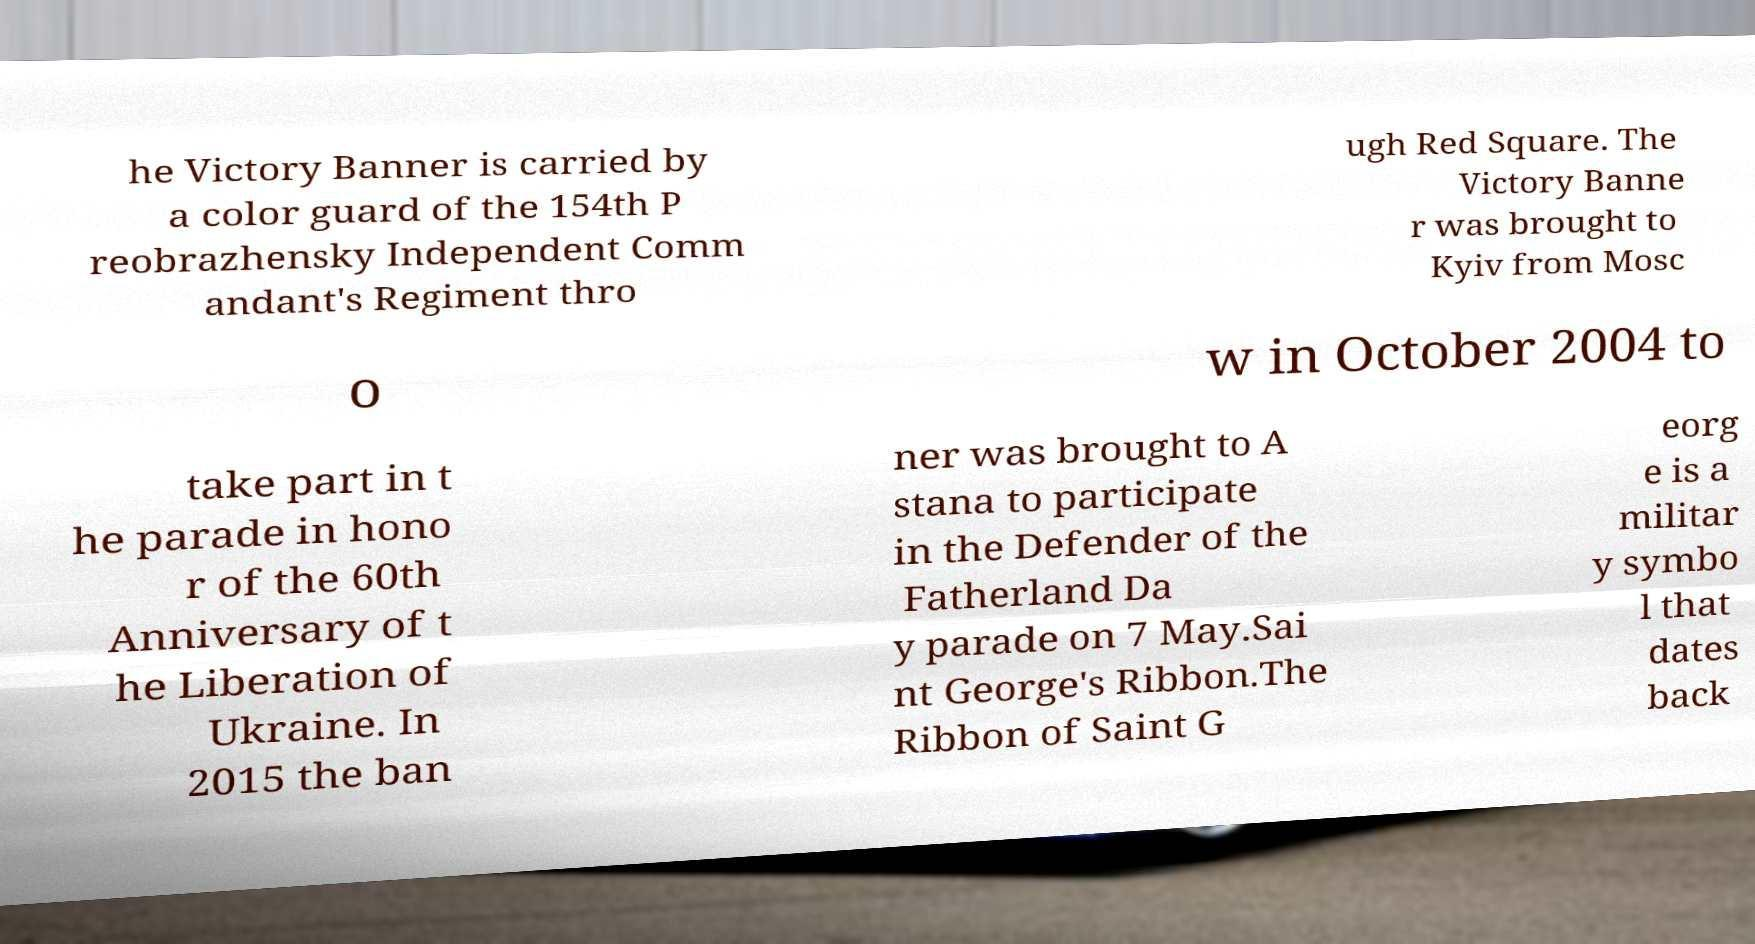Could you assist in decoding the text presented in this image and type it out clearly? he Victory Banner is carried by a color guard of the 154th P reobrazhensky Independent Comm andant's Regiment thro ugh Red Square. The Victory Banne r was brought to Kyiv from Mosc o w in October 2004 to take part in t he parade in hono r of the 60th Anniversary of t he Liberation of Ukraine. In 2015 the ban ner was brought to A stana to participate in the Defender of the Fatherland Da y parade on 7 May.Sai nt George's Ribbon.The Ribbon of Saint G eorg e is a militar y symbo l that dates back 